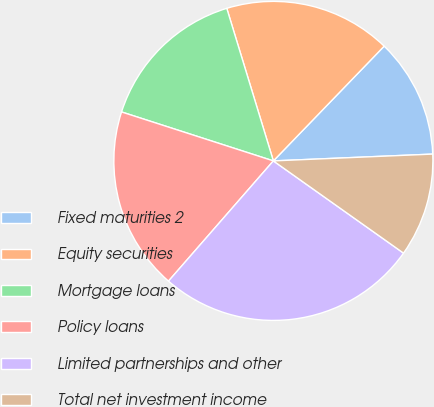Convert chart to OTSL. <chart><loc_0><loc_0><loc_500><loc_500><pie_chart><fcel>Fixed maturities 2<fcel>Equity securities<fcel>Mortgage loans<fcel>Policy loans<fcel>Limited partnerships and other<fcel>Total net investment income<nl><fcel>12.1%<fcel>16.94%<fcel>15.32%<fcel>18.55%<fcel>26.61%<fcel>10.49%<nl></chart> 